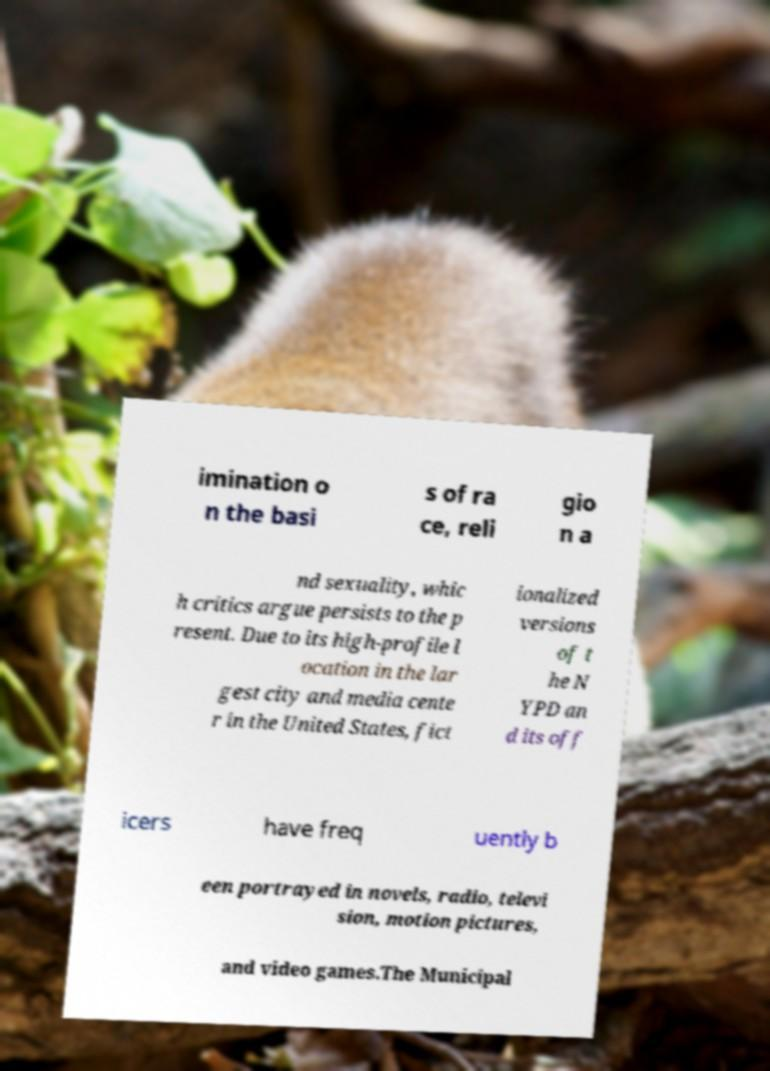There's text embedded in this image that I need extracted. Can you transcribe it verbatim? imination o n the basi s of ra ce, reli gio n a nd sexuality, whic h critics argue persists to the p resent. Due to its high-profile l ocation in the lar gest city and media cente r in the United States, fict ionalized versions of t he N YPD an d its off icers have freq uently b een portrayed in novels, radio, televi sion, motion pictures, and video games.The Municipal 